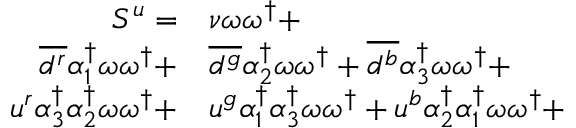Convert formula to latex. <formula><loc_0><loc_0><loc_500><loc_500>\begin{array} { r l } { S ^ { u } = } & { \nu } \omega \omega ^ { \dagger } + } \\ { \overline { { d ^ { r } } } { \alpha _ { 1 } ^ { \dagger } } \omega \omega ^ { \dagger } + } & \overline { { d ^ { g } } } { \alpha _ { 2 } ^ { \dagger } } \omega \omega ^ { \dagger } + \overline { { d ^ { b } } } { \alpha _ { 3 } ^ { \dagger } } \omega \omega ^ { \dagger } + } \\ { u ^ { r } { \alpha _ { 3 } ^ { \dagger } } { \alpha _ { 2 } ^ { \dagger } } \omega \omega ^ { \dagger } + } & u ^ { g } { \alpha _ { 1 } ^ { \dagger } } { \alpha _ { 3 } ^ { \dagger } } \omega \omega ^ { \dagger } + u ^ { b } { \alpha _ { 2 } ^ { \dagger } } { \alpha _ { 1 } ^ { \dagger } } \omega \omega ^ { \dagger } + } \end{array}</formula> 